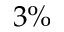Convert formula to latex. <formula><loc_0><loc_0><loc_500><loc_500>3 \%</formula> 